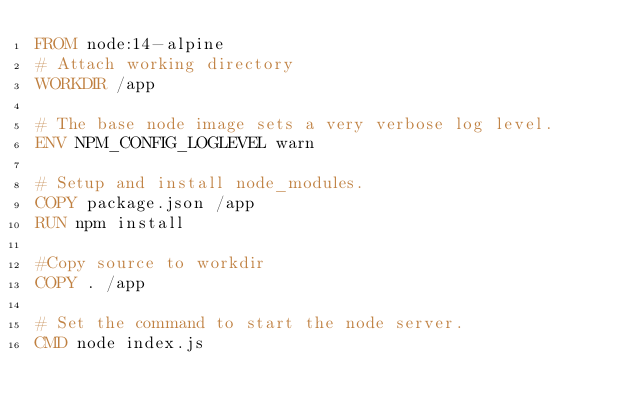<code> <loc_0><loc_0><loc_500><loc_500><_Dockerfile_>FROM node:14-alpine
# Attach working directory
WORKDIR /app

# The base node image sets a very verbose log level.
ENV NPM_CONFIG_LOGLEVEL warn

# Setup and install node_modules.
COPY package.json /app
RUN npm install

#Copy source to workdir
COPY . /app

# Set the command to start the node server.
CMD node index.js

</code> 